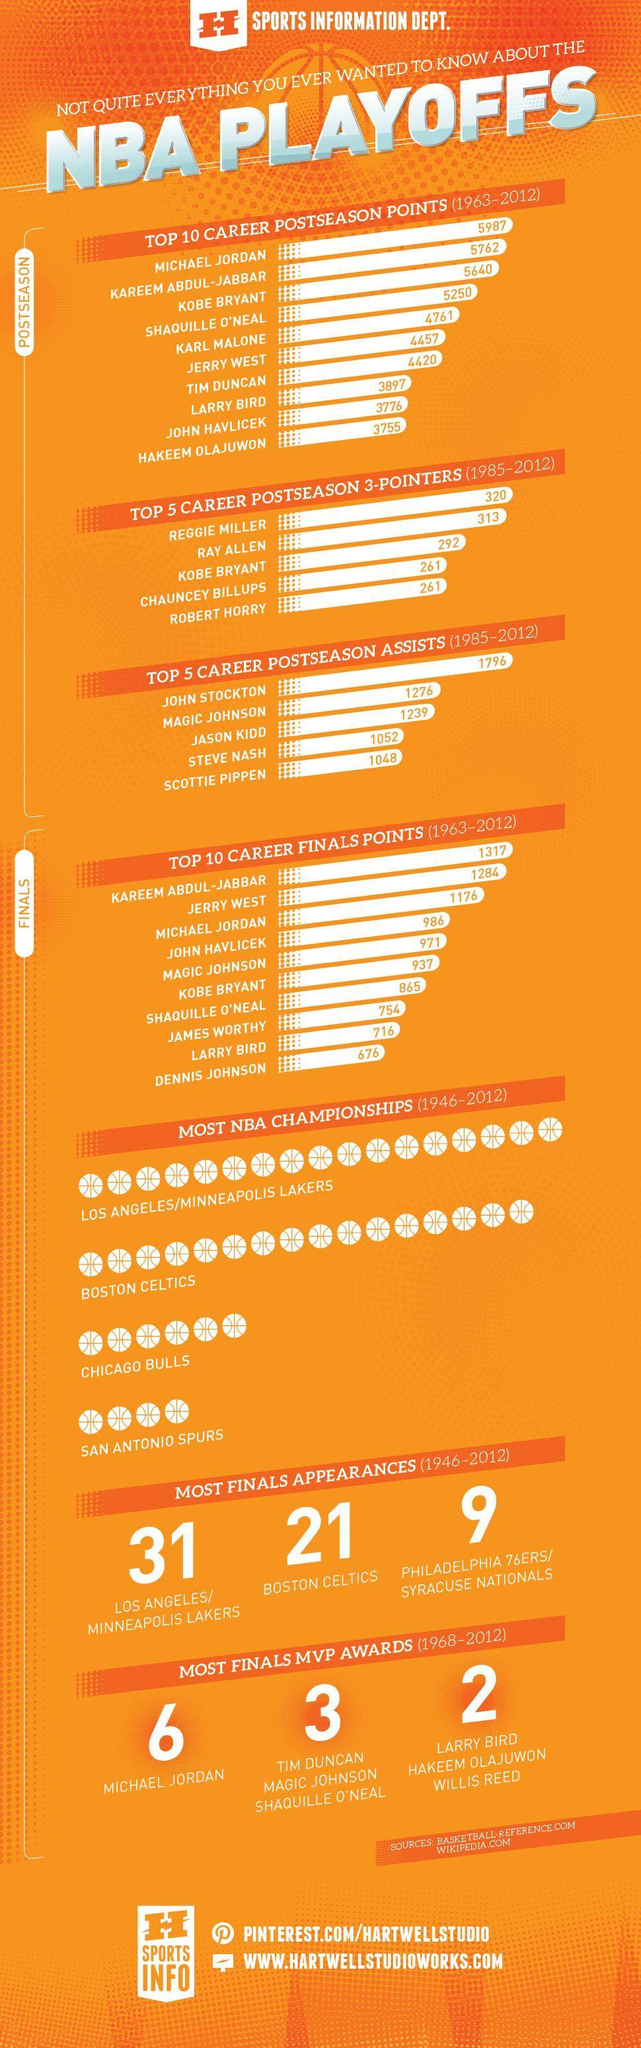How many postseason points did Jerry West score, more than Tim Duncan?
Answer the question with a short phrase. 37 How many post season 3 pointers did Kobe Bryant make? 292 Which players won 3 finals MVP awards each? Tim Duncan, Magic Johnson, Shaquille O'neal Which team made 21 finals appearances? Boston Celtics How many finals MVP awards did Willis Reed get? 2 Who won the most finals MVP awards? Michael Jordan Who are the players who scored less than 4000 postseason points? Larry Bird, John Havlicek, Hakeem Olajuwon Which team has won the least NBA championships? San Antonio Spurs Who stood third in the top 10 Career finals points? Michael Jordan Who scored the highest postseason points and how many? Michael Jordan, 5987 Which team won the third highest number of NBA championships? Chicago Bulls Who scored more postseason points Kobe Bryant or Tim Duncan? Kobe Bryant 